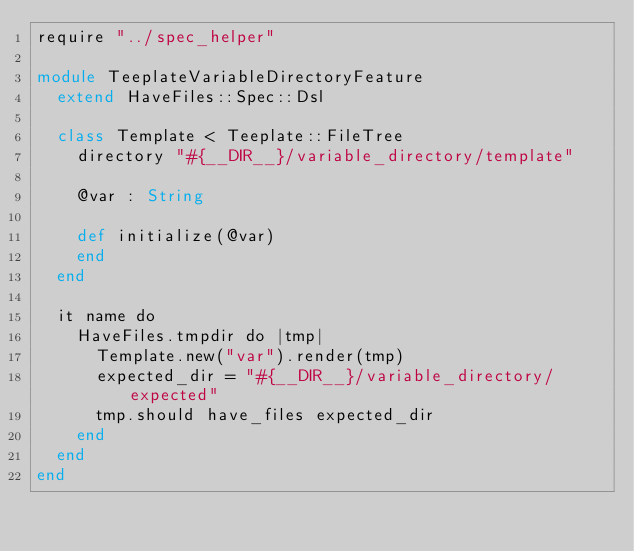Convert code to text. <code><loc_0><loc_0><loc_500><loc_500><_Crystal_>require "../spec_helper"

module TeeplateVariableDirectoryFeature
  extend HaveFiles::Spec::Dsl

  class Template < Teeplate::FileTree
    directory "#{__DIR__}/variable_directory/template"

    @var : String

    def initialize(@var)
    end
  end

  it name do
    HaveFiles.tmpdir do |tmp|
      Template.new("var").render(tmp)
      expected_dir = "#{__DIR__}/variable_directory/expected"
      tmp.should have_files expected_dir
    end
  end
end
</code> 